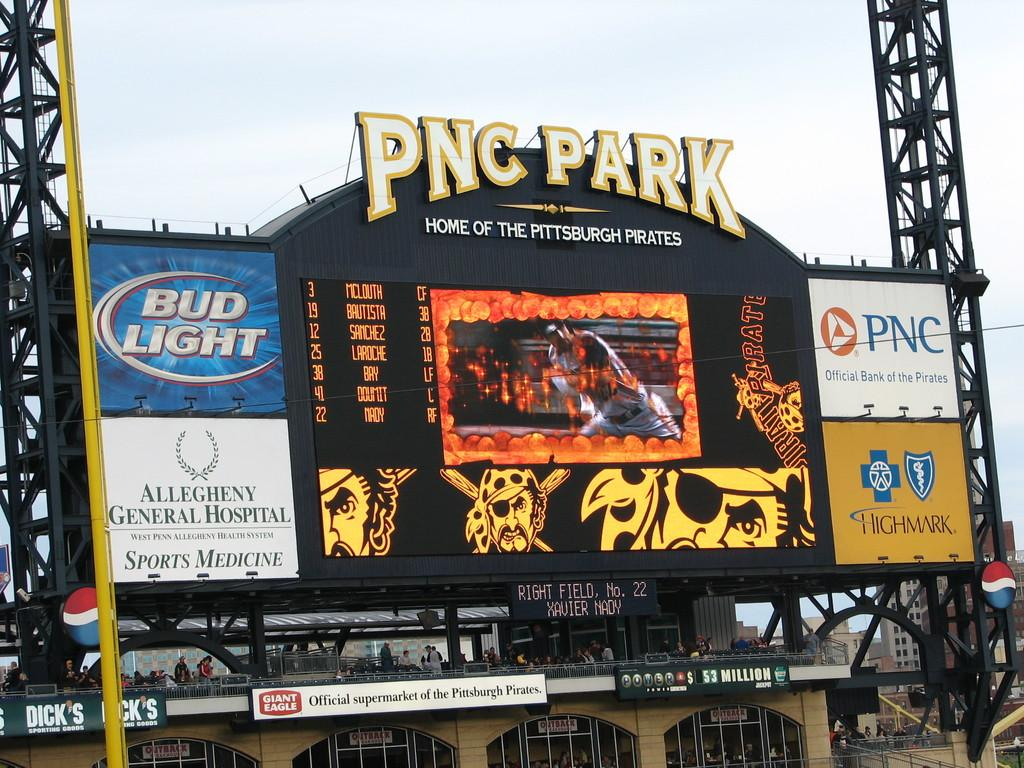Provide a one-sentence caption for the provided image. An electronic billboard at the home of the Pittsburgh Pirates is showing scores and advertisements for Bud Light, Allegheny General Hospital, PNC, And Highmark. 